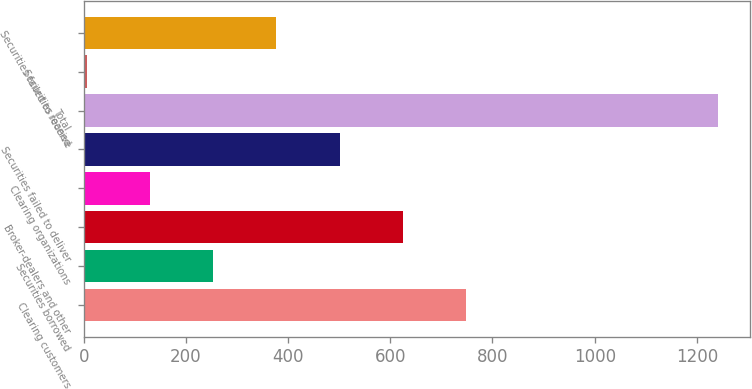Convert chart. <chart><loc_0><loc_0><loc_500><loc_500><bar_chart><fcel>Clearing customers<fcel>Securities borrowed<fcel>Broker-dealers and other<fcel>Clearing organizations<fcel>Securities failed to deliver<fcel>Total<fcel>Securities loaned<fcel>Securities failed to receive<nl><fcel>747.52<fcel>253.84<fcel>624.1<fcel>130.42<fcel>500.68<fcel>1241.2<fcel>7<fcel>377.26<nl></chart> 